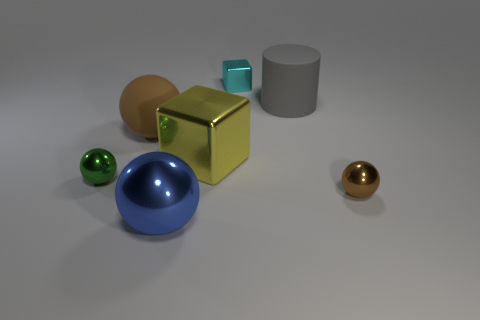Subtract all blue cubes. How many brown spheres are left? 2 Subtract all tiny brown metal balls. How many balls are left? 3 Subtract 1 spheres. How many spheres are left? 3 Subtract all blue balls. How many balls are left? 3 Add 2 small things. How many objects exist? 9 Subtract all cylinders. How many objects are left? 6 Add 7 cyan metal cylinders. How many cyan metal cylinders exist? 7 Subtract 0 blue blocks. How many objects are left? 7 Subtract all gray spheres. Subtract all red cylinders. How many spheres are left? 4 Subtract all balls. Subtract all red matte spheres. How many objects are left? 3 